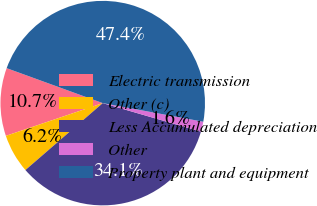Convert chart. <chart><loc_0><loc_0><loc_500><loc_500><pie_chart><fcel>Electric transmission<fcel>Other (c)<fcel>Less Accumulated depreciation<fcel>Other<fcel>Property plant and equipment<nl><fcel>10.74%<fcel>6.17%<fcel>34.14%<fcel>1.59%<fcel>47.36%<nl></chart> 